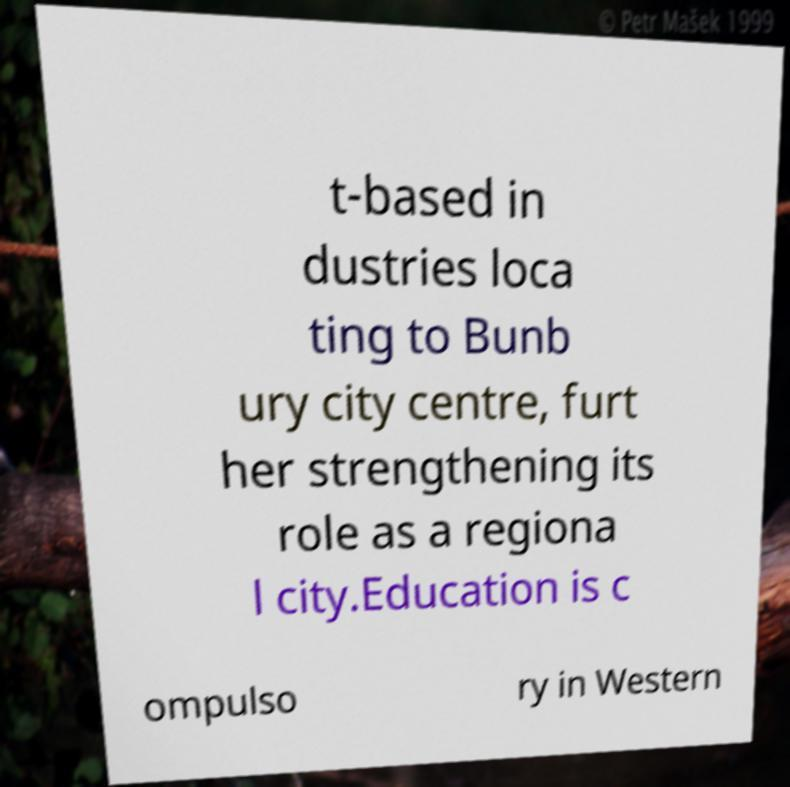For documentation purposes, I need the text within this image transcribed. Could you provide that? t-based in dustries loca ting to Bunb ury city centre, furt her strengthening its role as a regiona l city.Education is c ompulso ry in Western 